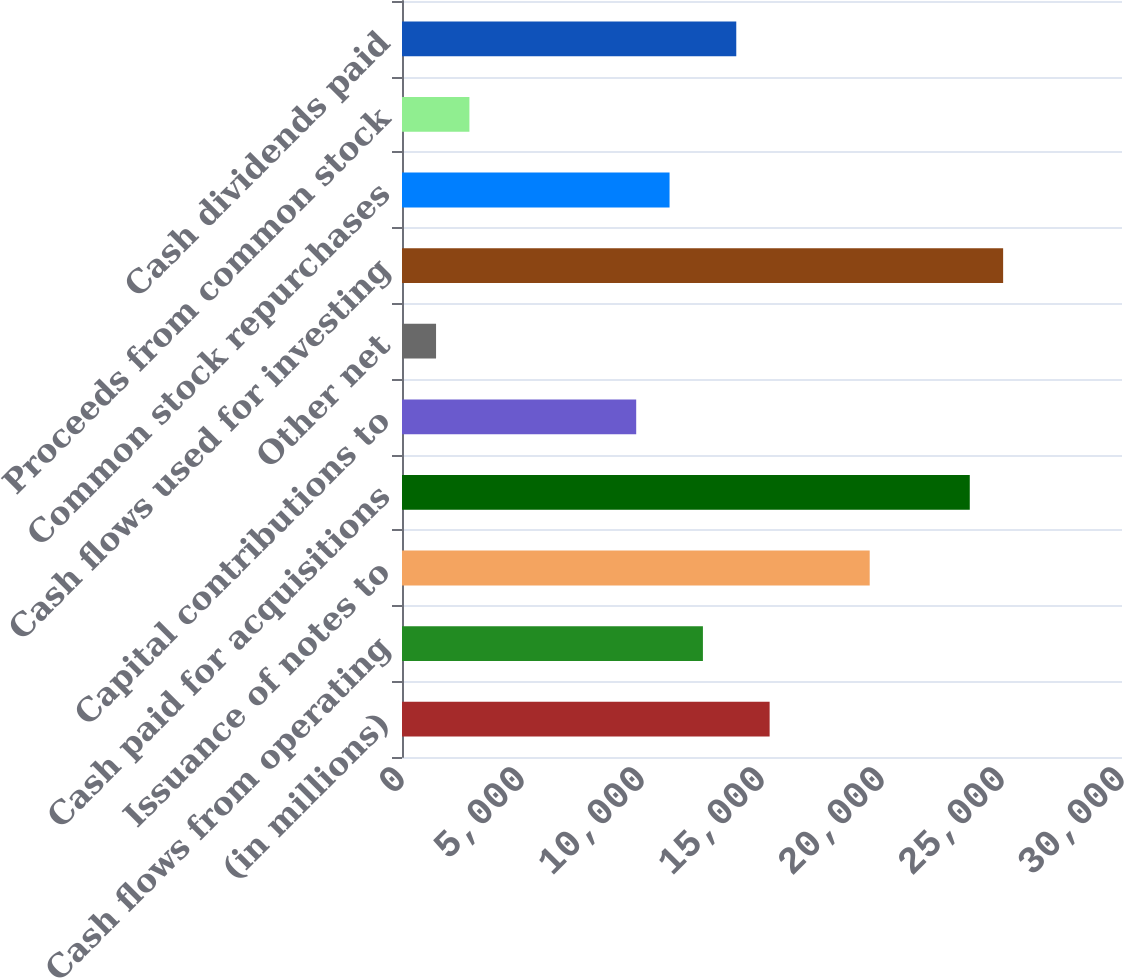Convert chart. <chart><loc_0><loc_0><loc_500><loc_500><bar_chart><fcel>(in millions)<fcel>Cash flows from operating<fcel>Issuance of notes to<fcel>Cash paid for acquisitions<fcel>Capital contributions to<fcel>Other net<fcel>Cash flows used for investing<fcel>Common stock repurchases<fcel>Proceeds from common stock<fcel>Cash dividends paid<nl><fcel>15317.9<fcel>12538.1<fcel>19487.6<fcel>23657.3<fcel>9758.3<fcel>1418.9<fcel>25047.2<fcel>11148.2<fcel>2808.8<fcel>13928<nl></chart> 